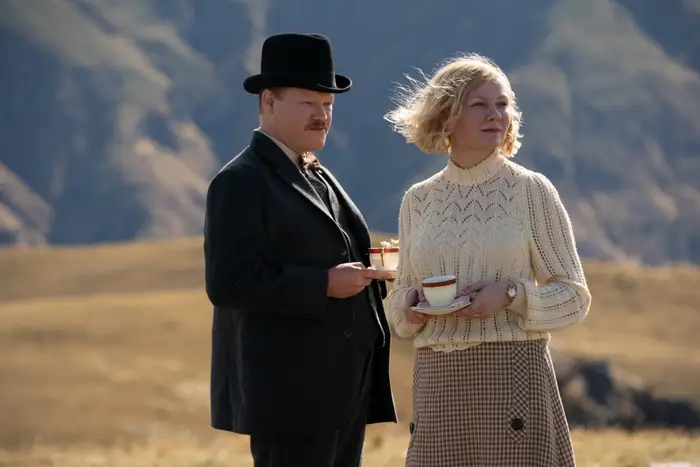How do the outfits of the characters help in defining their roles or personalities? The man's formal, somber black suit and top hat suggest a role of authority or a conventional, perhaps conservative personality, possibly indicating his societal status or responsibilities. In contrast, the woman’s white sweater and patterned skirt offer a softer, more approachable look, which might hint at her own vulnerability or openness in the narrative, setting a visual contrast that reflects their differing roles or emotional states. Could there be any symbolic meaning to the tea they’re holding? Yes, the tea could symbolize comfort and ritual, suggesting a moment of pause or connection amidst potential turmoil. It might also hint at attempts to preserve normalcy or civility in a situation where such qualities are in jeopardy, acting as a subtle metaphor for personal or relational stability. 